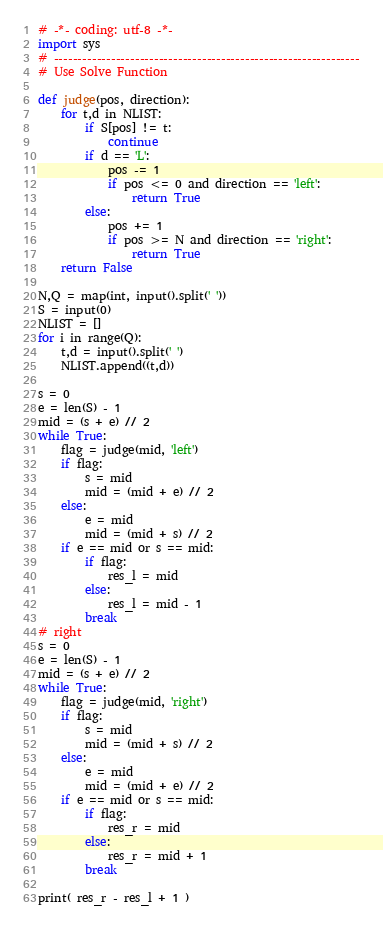Convert code to text. <code><loc_0><loc_0><loc_500><loc_500><_Python_># -*- coding: utf-8 -*-
import sys
# ----------------------------------------------------------------
# Use Solve Function

def judge(pos, direction):
    for t,d in NLIST:
        if S[pos] != t:
            continue
        if d == 'L':
            pos -= 1
            if pos <= 0 and direction == 'left':
                return True
        else:
            pos += 1
            if pos >= N and direction == 'right':
                return True
    return False

N,Q = map(int, input().split(' '))
S = input(0)
NLIST = []
for i in range(Q):
    t,d = input().split(' ')
    NLIST.append((t,d))

s = 0
e = len(S) - 1
mid = (s + e) // 2
while True:
    flag = judge(mid, 'left')
    if flag:
        s = mid
        mid = (mid + e) // 2
    else:
        e = mid
        mid = (mid + s) // 2
    if e == mid or s == mid:
        if flag:
            res_l = mid
        else:
            res_l = mid - 1
        break
# right
s = 0
e = len(S) - 1
mid = (s + e) // 2
while True:
    flag = judge(mid, 'right')
    if flag:
        s = mid
        mid = (mid + s) // 2
    else:
        e = mid
        mid = (mid + e) // 2
    if e == mid or s == mid:
        if flag:
            res_r = mid
        else:
            res_r = mid + 1
        break

print( res_r - res_l + 1 )</code> 